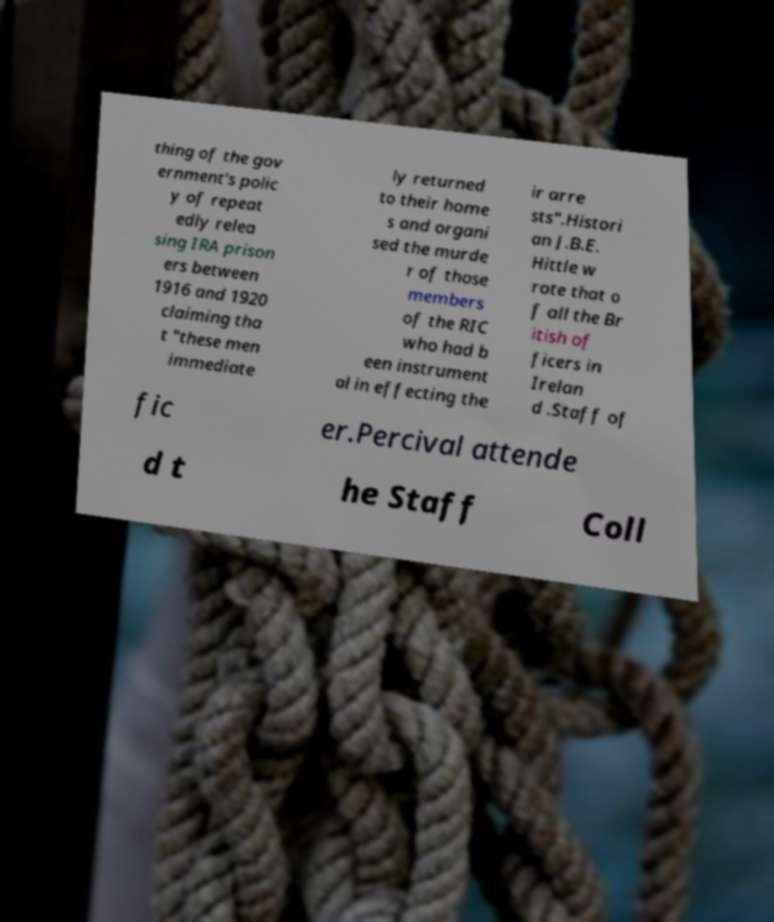Please read and relay the text visible in this image. What does it say? thing of the gov ernment's polic y of repeat edly relea sing IRA prison ers between 1916 and 1920 claiming tha t "these men immediate ly returned to their home s and organi sed the murde r of those members of the RIC who had b een instrument al in effecting the ir arre sts".Histori an J.B.E. Hittle w rote that o f all the Br itish of ficers in Irelan d .Staff of fic er.Percival attende d t he Staff Coll 